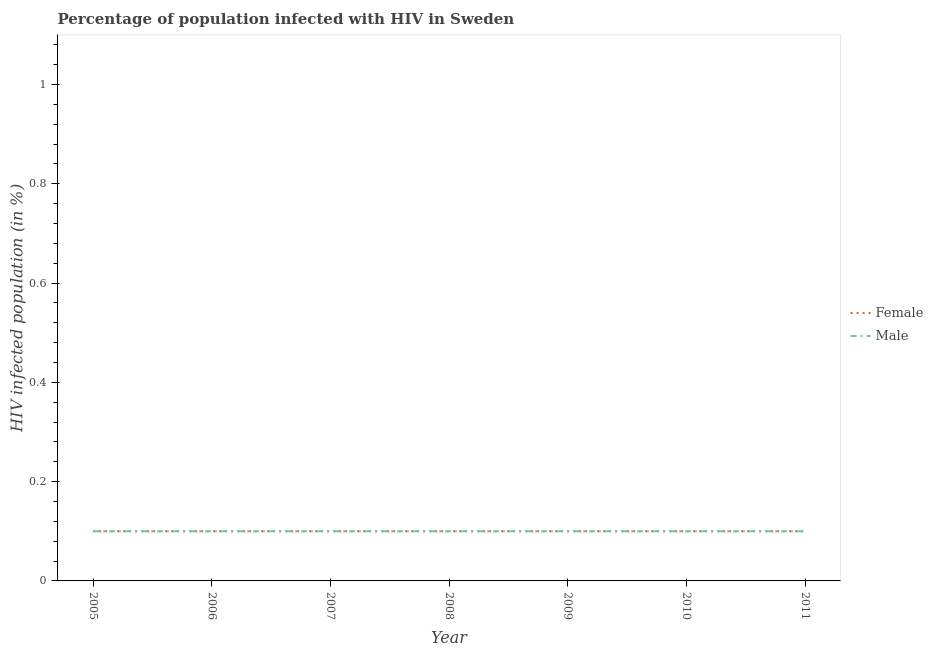How many different coloured lines are there?
Give a very brief answer. 2. Across all years, what is the maximum percentage of males who are infected with hiv?
Your response must be concise. 0.1. Across all years, what is the minimum percentage of females who are infected with hiv?
Your response must be concise. 0.1. What is the total percentage of males who are infected with hiv in the graph?
Your response must be concise. 0.7. What is the difference between the percentage of males who are infected with hiv in 2008 and that in 2009?
Ensure brevity in your answer.  0. What is the difference between the percentage of females who are infected with hiv in 2007 and the percentage of males who are infected with hiv in 2011?
Your answer should be very brief. 0. What is the average percentage of females who are infected with hiv per year?
Provide a short and direct response. 0.1. In the year 2010, what is the difference between the percentage of females who are infected with hiv and percentage of males who are infected with hiv?
Keep it short and to the point. 0. In how many years, is the percentage of males who are infected with hiv greater than 0.12 %?
Your response must be concise. 0. What is the ratio of the percentage of males who are infected with hiv in 2006 to that in 2011?
Ensure brevity in your answer.  1. Does the percentage of males who are infected with hiv monotonically increase over the years?
Keep it short and to the point. No. Is the percentage of females who are infected with hiv strictly less than the percentage of males who are infected with hiv over the years?
Keep it short and to the point. No. How many years are there in the graph?
Keep it short and to the point. 7. What is the difference between two consecutive major ticks on the Y-axis?
Your response must be concise. 0.2. Are the values on the major ticks of Y-axis written in scientific E-notation?
Your answer should be very brief. No. Does the graph contain any zero values?
Your answer should be very brief. No. How many legend labels are there?
Your response must be concise. 2. What is the title of the graph?
Ensure brevity in your answer.  Percentage of population infected with HIV in Sweden. Does "Personal remittances" appear as one of the legend labels in the graph?
Your answer should be very brief. No. What is the label or title of the Y-axis?
Offer a very short reply. HIV infected population (in %). What is the HIV infected population (in %) in Female in 2005?
Your answer should be compact. 0.1. What is the HIV infected population (in %) in Male in 2005?
Provide a succinct answer. 0.1. What is the HIV infected population (in %) of Male in 2006?
Ensure brevity in your answer.  0.1. What is the HIV infected population (in %) in Male in 2007?
Your answer should be compact. 0.1. What is the HIV infected population (in %) in Female in 2008?
Provide a short and direct response. 0.1. What is the HIV infected population (in %) in Male in 2008?
Provide a succinct answer. 0.1. What is the HIV infected population (in %) in Male in 2009?
Offer a very short reply. 0.1. What is the HIV infected population (in %) in Male in 2011?
Offer a very short reply. 0.1. Across all years, what is the minimum HIV infected population (in %) in Female?
Provide a short and direct response. 0.1. What is the difference between the HIV infected population (in %) in Female in 2005 and that in 2007?
Give a very brief answer. 0. What is the difference between the HIV infected population (in %) in Male in 2005 and that in 2008?
Your answer should be very brief. 0. What is the difference between the HIV infected population (in %) of Female in 2005 and that in 2010?
Offer a terse response. 0. What is the difference between the HIV infected population (in %) in Male in 2005 and that in 2010?
Offer a terse response. 0. What is the difference between the HIV infected population (in %) in Male in 2005 and that in 2011?
Your answer should be very brief. 0. What is the difference between the HIV infected population (in %) in Female in 2006 and that in 2007?
Ensure brevity in your answer.  0. What is the difference between the HIV infected population (in %) in Male in 2006 and that in 2007?
Keep it short and to the point. 0. What is the difference between the HIV infected population (in %) in Male in 2006 and that in 2009?
Provide a short and direct response. 0. What is the difference between the HIV infected population (in %) of Female in 2006 and that in 2010?
Your answer should be very brief. 0. What is the difference between the HIV infected population (in %) of Female in 2006 and that in 2011?
Provide a short and direct response. 0. What is the difference between the HIV infected population (in %) of Male in 2006 and that in 2011?
Give a very brief answer. 0. What is the difference between the HIV infected population (in %) of Female in 2007 and that in 2008?
Give a very brief answer. 0. What is the difference between the HIV infected population (in %) in Male in 2007 and that in 2010?
Offer a terse response. 0. What is the difference between the HIV infected population (in %) in Male in 2008 and that in 2009?
Make the answer very short. 0. What is the difference between the HIV infected population (in %) of Female in 2008 and that in 2011?
Keep it short and to the point. 0. What is the difference between the HIV infected population (in %) of Male in 2008 and that in 2011?
Offer a very short reply. 0. What is the difference between the HIV infected population (in %) of Female in 2009 and that in 2010?
Ensure brevity in your answer.  0. What is the difference between the HIV infected population (in %) of Male in 2010 and that in 2011?
Give a very brief answer. 0. What is the difference between the HIV infected population (in %) in Female in 2005 and the HIV infected population (in %) in Male in 2007?
Keep it short and to the point. 0. What is the difference between the HIV infected population (in %) of Female in 2005 and the HIV infected population (in %) of Male in 2009?
Make the answer very short. 0. What is the difference between the HIV infected population (in %) of Female in 2005 and the HIV infected population (in %) of Male in 2010?
Offer a very short reply. 0. What is the difference between the HIV infected population (in %) in Female in 2006 and the HIV infected population (in %) in Male in 2007?
Keep it short and to the point. 0. What is the difference between the HIV infected population (in %) in Female in 2006 and the HIV infected population (in %) in Male in 2010?
Your answer should be compact. 0. What is the difference between the HIV infected population (in %) in Female in 2006 and the HIV infected population (in %) in Male in 2011?
Your answer should be compact. 0. What is the difference between the HIV infected population (in %) of Female in 2007 and the HIV infected population (in %) of Male in 2009?
Your response must be concise. 0. What is the difference between the HIV infected population (in %) of Female in 2007 and the HIV infected population (in %) of Male in 2010?
Provide a short and direct response. 0. What is the difference between the HIV infected population (in %) of Female in 2008 and the HIV infected population (in %) of Male in 2010?
Ensure brevity in your answer.  0. What is the difference between the HIV infected population (in %) in Female in 2009 and the HIV infected population (in %) in Male in 2011?
Give a very brief answer. 0. What is the average HIV infected population (in %) of Male per year?
Your answer should be compact. 0.1. In the year 2005, what is the difference between the HIV infected population (in %) of Female and HIV infected population (in %) of Male?
Offer a terse response. 0. In the year 2011, what is the difference between the HIV infected population (in %) of Female and HIV infected population (in %) of Male?
Offer a very short reply. 0. What is the ratio of the HIV infected population (in %) of Female in 2005 to that in 2006?
Offer a very short reply. 1. What is the ratio of the HIV infected population (in %) of Male in 2005 to that in 2006?
Keep it short and to the point. 1. What is the ratio of the HIV infected population (in %) of Female in 2005 to that in 2007?
Your answer should be compact. 1. What is the ratio of the HIV infected population (in %) of Male in 2005 to that in 2007?
Your response must be concise. 1. What is the ratio of the HIV infected population (in %) of Male in 2005 to that in 2008?
Give a very brief answer. 1. What is the ratio of the HIV infected population (in %) in Female in 2005 to that in 2009?
Your answer should be very brief. 1. What is the ratio of the HIV infected population (in %) in Female in 2005 to that in 2010?
Your answer should be very brief. 1. What is the ratio of the HIV infected population (in %) in Male in 2005 to that in 2011?
Your answer should be compact. 1. What is the ratio of the HIV infected population (in %) of Female in 2006 to that in 2008?
Offer a terse response. 1. What is the ratio of the HIV infected population (in %) in Male in 2006 to that in 2008?
Keep it short and to the point. 1. What is the ratio of the HIV infected population (in %) of Female in 2006 to that in 2009?
Provide a succinct answer. 1. What is the ratio of the HIV infected population (in %) of Male in 2006 to that in 2009?
Your answer should be very brief. 1. What is the ratio of the HIV infected population (in %) in Female in 2006 to that in 2011?
Give a very brief answer. 1. What is the ratio of the HIV infected population (in %) of Male in 2006 to that in 2011?
Your response must be concise. 1. What is the ratio of the HIV infected population (in %) of Male in 2007 to that in 2009?
Keep it short and to the point. 1. What is the ratio of the HIV infected population (in %) in Female in 2007 to that in 2010?
Give a very brief answer. 1. What is the ratio of the HIV infected population (in %) of Female in 2007 to that in 2011?
Make the answer very short. 1. What is the ratio of the HIV infected population (in %) of Male in 2007 to that in 2011?
Offer a very short reply. 1. What is the ratio of the HIV infected population (in %) in Male in 2009 to that in 2010?
Make the answer very short. 1. What is the ratio of the HIV infected population (in %) of Female in 2009 to that in 2011?
Ensure brevity in your answer.  1. What is the ratio of the HIV infected population (in %) of Male in 2009 to that in 2011?
Keep it short and to the point. 1. What is the ratio of the HIV infected population (in %) of Female in 2010 to that in 2011?
Your answer should be very brief. 1. 